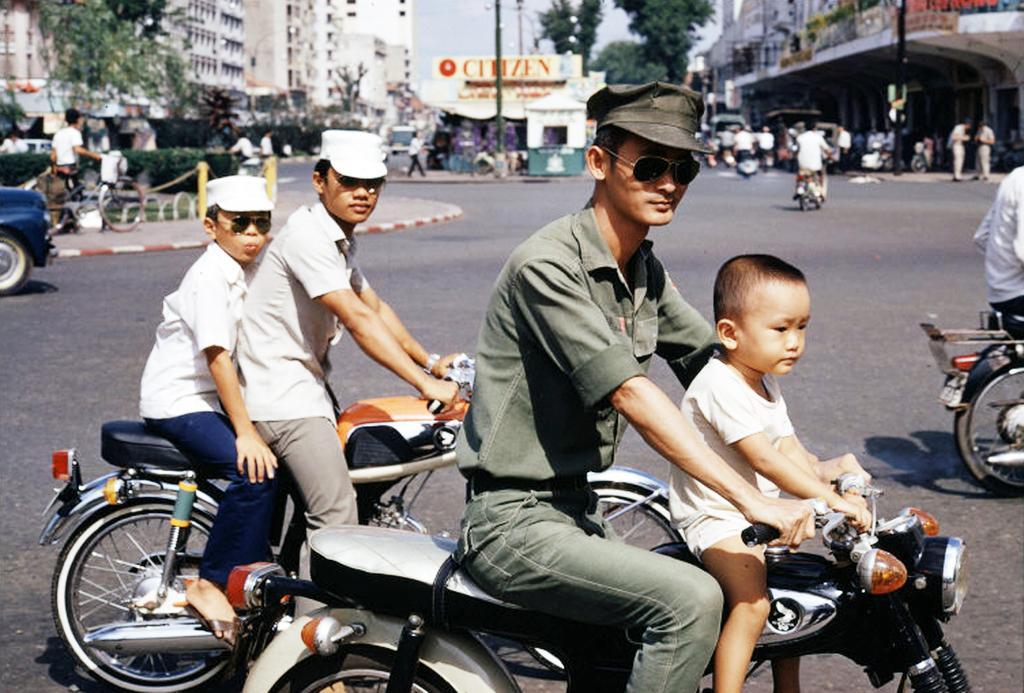In one or two sentences, can you explain what this image depicts? There are group of persons riding motorcycles and at the background of the image there is a building and trees and group of people. 